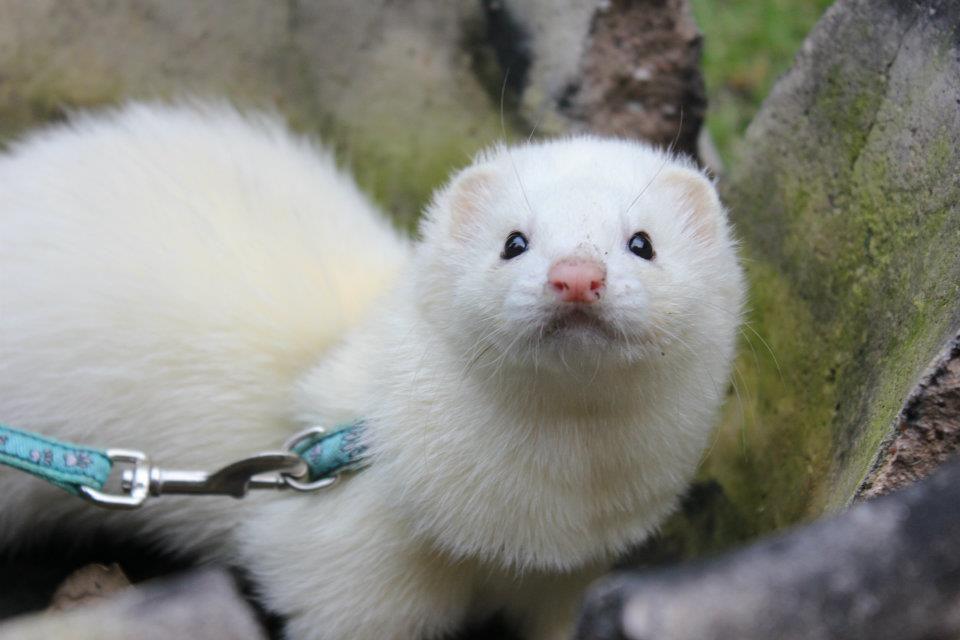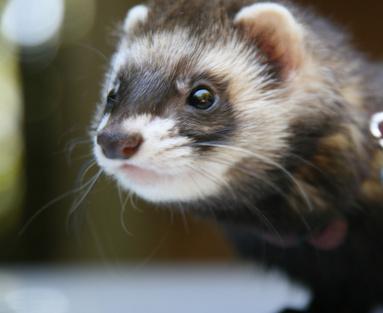The first image is the image on the left, the second image is the image on the right. Examine the images to the left and right. Is the description "At least one of the images has exactly one ferret." accurate? Answer yes or no. Yes. The first image is the image on the left, the second image is the image on the right. Considering the images on both sides, is "At least one image contains multiple ferrets, and at least one image includes a ferret in a resting pose." valid? Answer yes or no. No. 